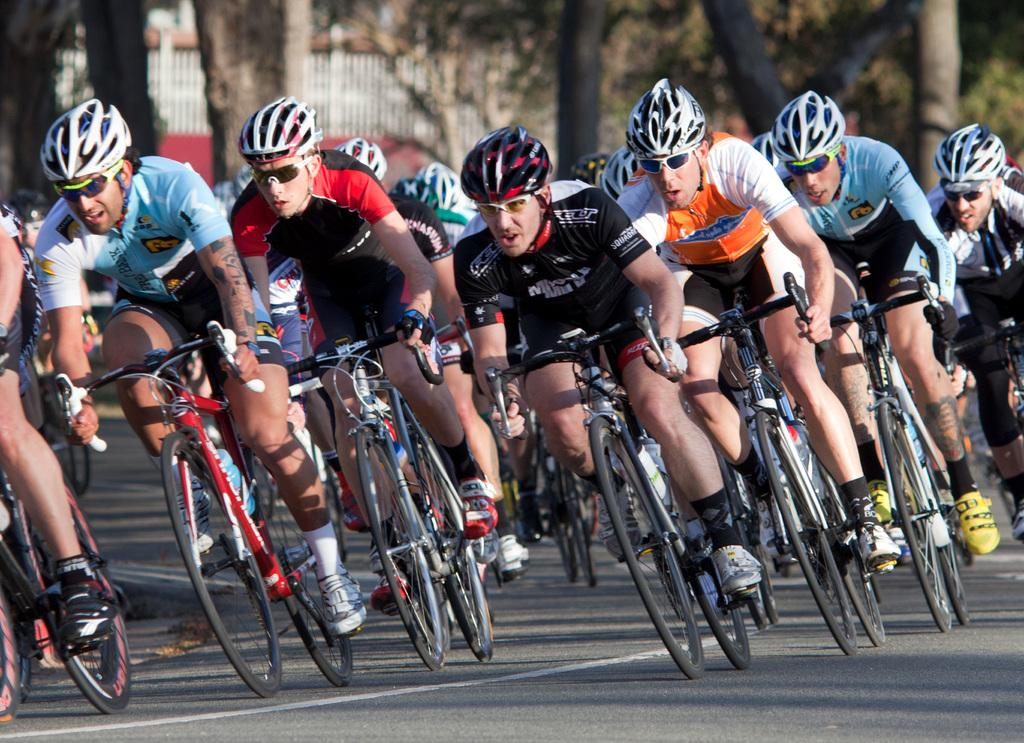How many people are in the image? There is a group of persons in the image. What are the persons wearing on their heads? The persons are wearing helmets. What are the persons wearing on their faces? The persons are wearing spectacles. What are the persons doing in the image? The persons are riding bicycles. Where are the bicycles located? The bicycles are on the road. What can be seen in the background of the image? There are trees visible in the image. What is present near the road in the image? There is a fence in the image. How much money is being exchanged between the persons while riding the bicycles? There is no indication of money being exchanged in the image; the persons are simply riding bicycles. 